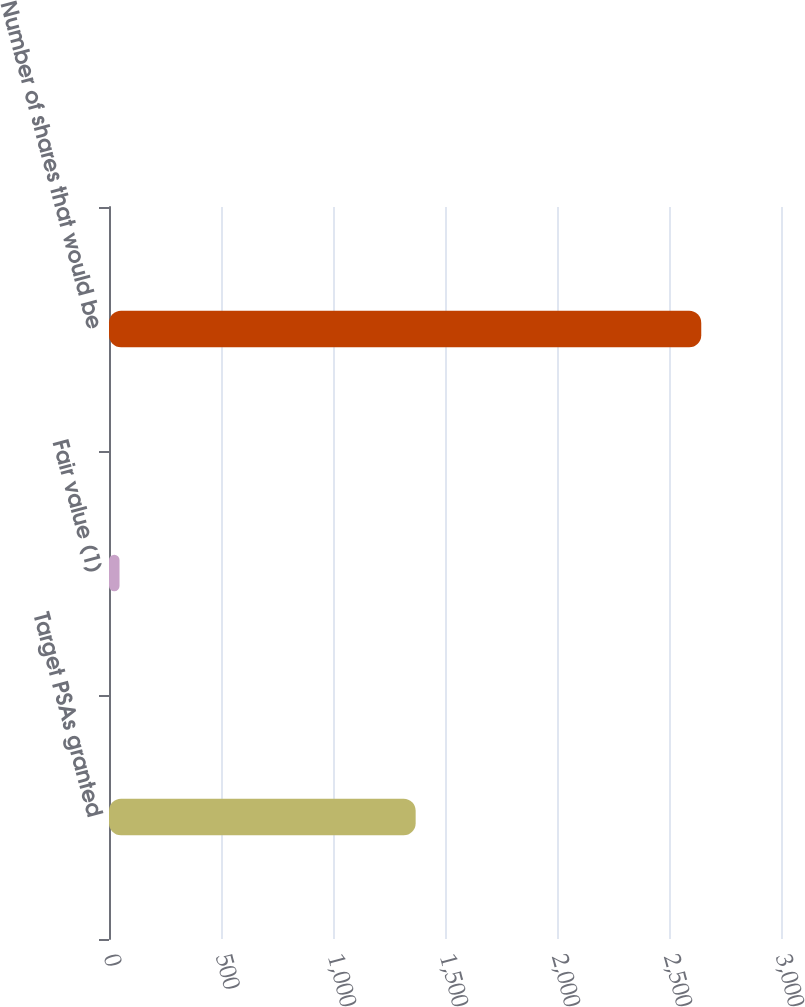Convert chart. <chart><loc_0><loc_0><loc_500><loc_500><bar_chart><fcel>Target PSAs granted<fcel>Fair value (1)<fcel>Number of shares that would be<nl><fcel>1369<fcel>47<fcel>2644<nl></chart> 